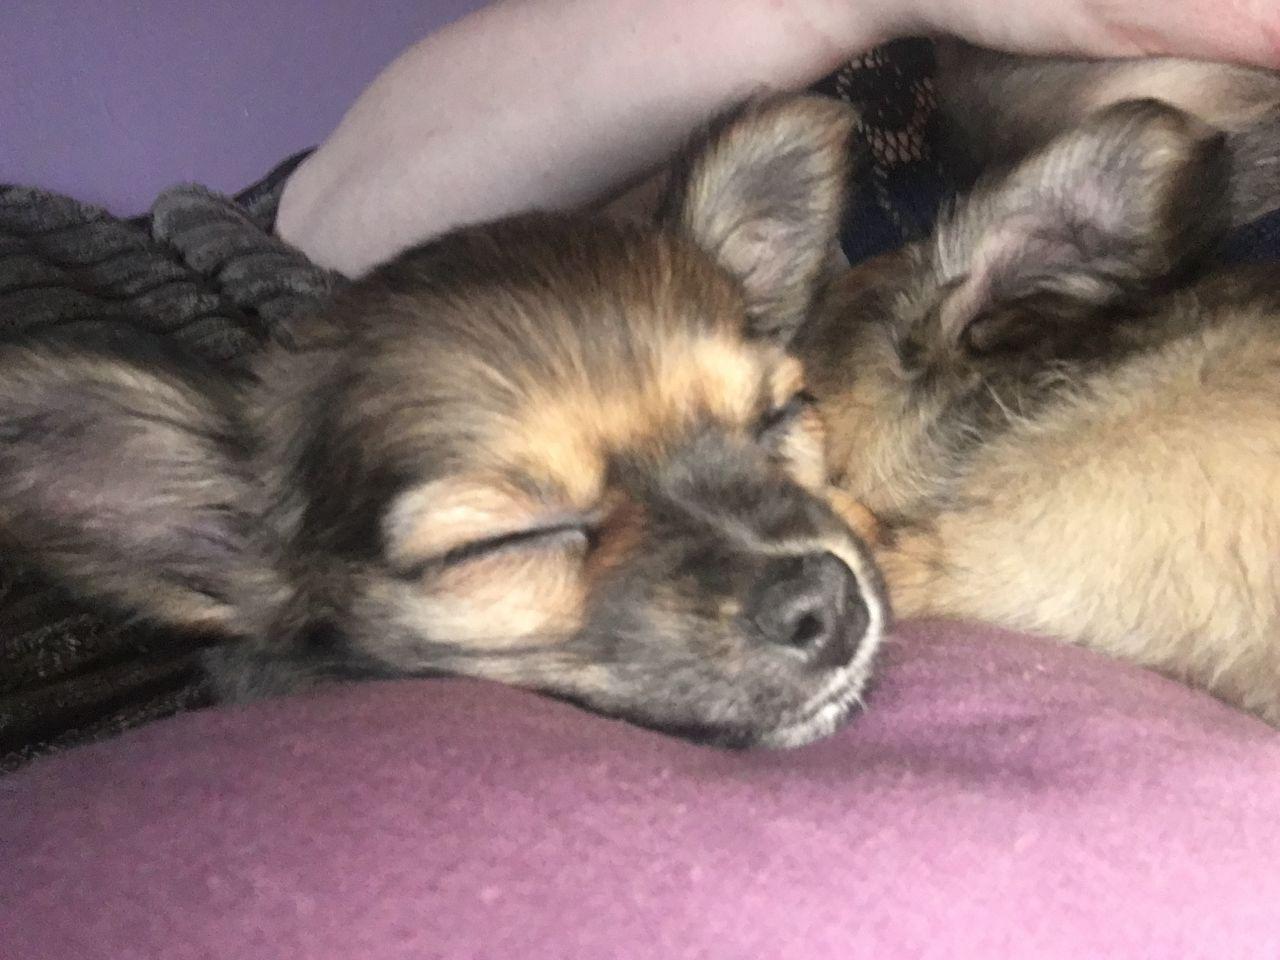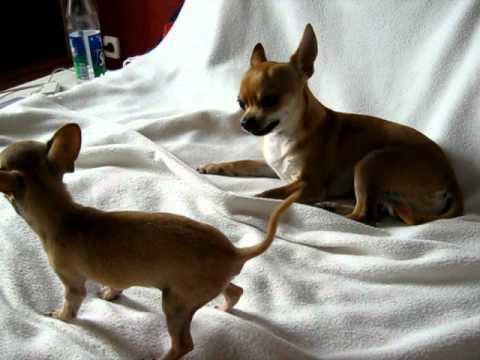The first image is the image on the left, the second image is the image on the right. Assess this claim about the two images: "In one image, two furry chihuahuas are posed sitting upright side-by-side, facing the camera.". Correct or not? Answer yes or no. No. The first image is the image on the left, the second image is the image on the right. Assess this claim about the two images: "There are two dogs standing in the grass in each of the images.". Correct or not? Answer yes or no. No. 